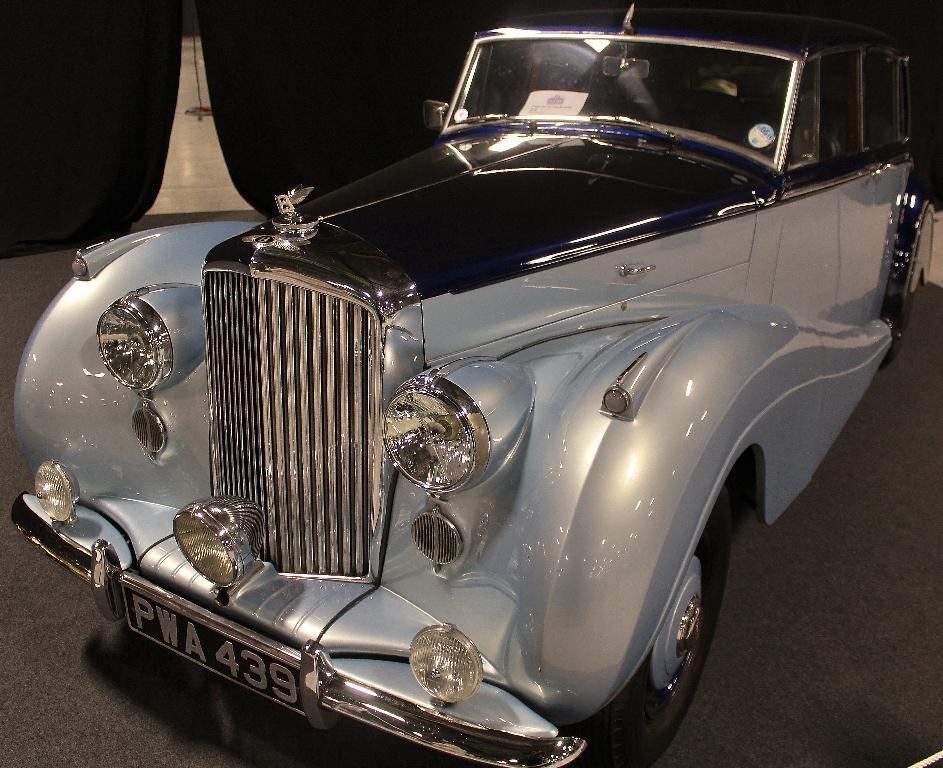What is the main subject in the center of the image? There is a car in the center of the image. What color is the background of the image? The background of the image is black. Can you describe the unspecified object in the image? Unfortunately, the provided facts do not give enough information to describe the unspecified object. What can be seen at the bottom of the image? The floor is visible at the bottom of the image. Where is the heart-shaped cart located in the image? There is no heart-shaped cart present in the image. Is there a collar visible on the car in the image? No, there is no collar visible on the car in the image. 